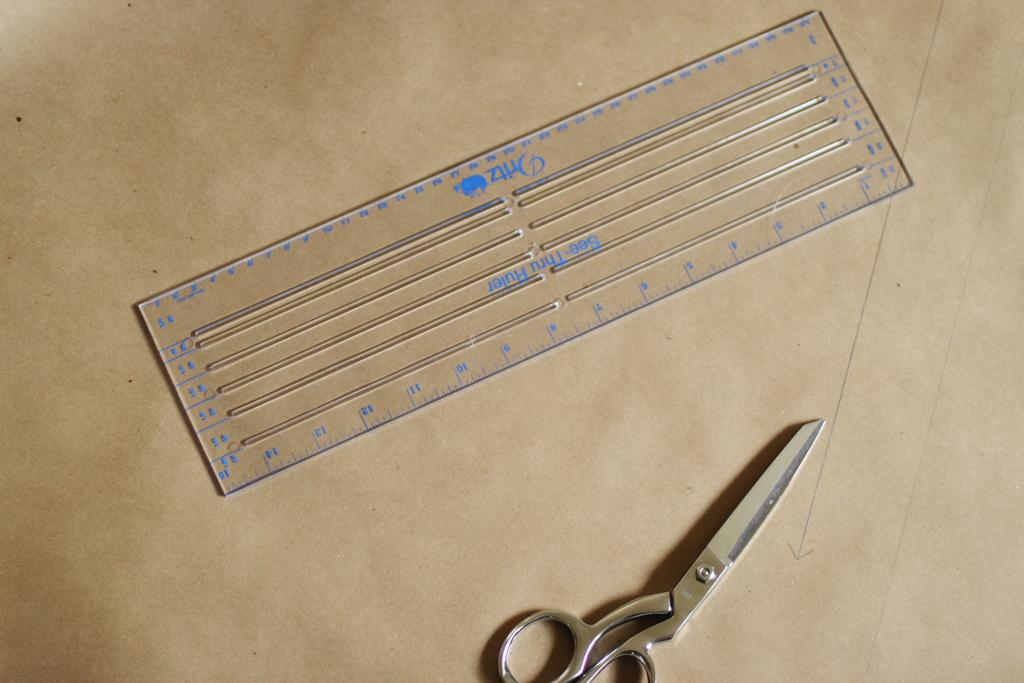<image>
Offer a succinct explanation of the picture presented. A "see through ruler" is on the left of metal scissors. 